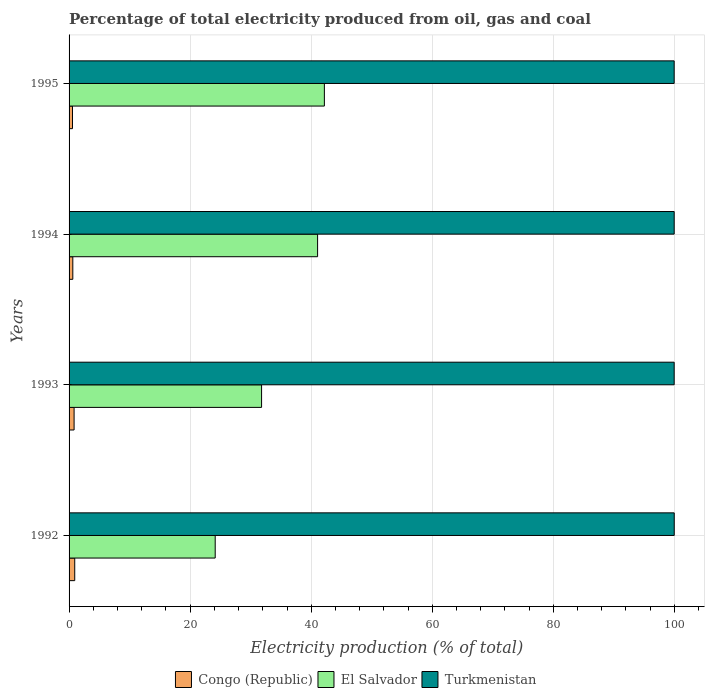How many groups of bars are there?
Provide a succinct answer. 4. Are the number of bars per tick equal to the number of legend labels?
Ensure brevity in your answer.  Yes. Are the number of bars on each tick of the Y-axis equal?
Your answer should be very brief. Yes. What is the electricity production in in Turkmenistan in 1995?
Your answer should be very brief. 99.96. Across all years, what is the maximum electricity production in in El Salvador?
Give a very brief answer. 42.18. Across all years, what is the minimum electricity production in in Turkmenistan?
Ensure brevity in your answer.  99.96. In which year was the electricity production in in Turkmenistan minimum?
Give a very brief answer. 1995. What is the total electricity production in in El Salvador in the graph?
Your answer should be compact. 139.17. What is the difference between the electricity production in in El Salvador in 1994 and that in 1995?
Offer a terse response. -1.12. What is the difference between the electricity production in in Turkmenistan in 1994 and the electricity production in in El Salvador in 1995?
Ensure brevity in your answer.  57.79. What is the average electricity production in in Turkmenistan per year?
Your response must be concise. 99.96. In the year 1994, what is the difference between the electricity production in in Congo (Republic) and electricity production in in El Salvador?
Make the answer very short. -40.44. What is the ratio of the electricity production in in Congo (Republic) in 1993 to that in 1994?
Ensure brevity in your answer.  1.34. Is the difference between the electricity production in in Congo (Republic) in 1993 and 1994 greater than the difference between the electricity production in in El Salvador in 1993 and 1994?
Offer a terse response. Yes. What is the difference between the highest and the second highest electricity production in in El Salvador?
Provide a succinct answer. 1.12. What is the difference between the highest and the lowest electricity production in in Turkmenistan?
Ensure brevity in your answer.  0.01. In how many years, is the electricity production in in Turkmenistan greater than the average electricity production in in Turkmenistan taken over all years?
Your response must be concise. 1. What does the 3rd bar from the top in 1994 represents?
Your answer should be compact. Congo (Republic). What does the 1st bar from the bottom in 1993 represents?
Your answer should be very brief. Congo (Republic). Is it the case that in every year, the sum of the electricity production in in El Salvador and electricity production in in Turkmenistan is greater than the electricity production in in Congo (Republic)?
Make the answer very short. Yes. How many bars are there?
Your response must be concise. 12. How many years are there in the graph?
Your answer should be compact. 4. Does the graph contain any zero values?
Your answer should be compact. No. Does the graph contain grids?
Offer a terse response. Yes. How are the legend labels stacked?
Your response must be concise. Horizontal. What is the title of the graph?
Your answer should be compact. Percentage of total electricity produced from oil, gas and coal. What is the label or title of the X-axis?
Ensure brevity in your answer.  Electricity production (% of total). What is the Electricity production (% of total) of Congo (Republic) in 1992?
Provide a short and direct response. 0.93. What is the Electricity production (% of total) in El Salvador in 1992?
Offer a very short reply. 24.14. What is the Electricity production (% of total) of Turkmenistan in 1992?
Your answer should be compact. 99.97. What is the Electricity production (% of total) of Congo (Republic) in 1993?
Your answer should be very brief. 0.83. What is the Electricity production (% of total) of El Salvador in 1993?
Provide a short and direct response. 31.8. What is the Electricity production (% of total) in Turkmenistan in 1993?
Make the answer very short. 99.96. What is the Electricity production (% of total) in Congo (Republic) in 1994?
Your answer should be very brief. 0.62. What is the Electricity production (% of total) in El Salvador in 1994?
Ensure brevity in your answer.  41.05. What is the Electricity production (% of total) of Turkmenistan in 1994?
Ensure brevity in your answer.  99.96. What is the Electricity production (% of total) of Congo (Republic) in 1995?
Your answer should be very brief. 0.56. What is the Electricity production (% of total) of El Salvador in 1995?
Your response must be concise. 42.18. What is the Electricity production (% of total) in Turkmenistan in 1995?
Your response must be concise. 99.96. Across all years, what is the maximum Electricity production (% of total) in Congo (Republic)?
Offer a very short reply. 0.93. Across all years, what is the maximum Electricity production (% of total) of El Salvador?
Your answer should be compact. 42.18. Across all years, what is the maximum Electricity production (% of total) in Turkmenistan?
Ensure brevity in your answer.  99.97. Across all years, what is the minimum Electricity production (% of total) in Congo (Republic)?
Keep it short and to the point. 0.56. Across all years, what is the minimum Electricity production (% of total) in El Salvador?
Keep it short and to the point. 24.14. Across all years, what is the minimum Electricity production (% of total) of Turkmenistan?
Offer a very short reply. 99.96. What is the total Electricity production (% of total) in Congo (Republic) in the graph?
Your response must be concise. 2.95. What is the total Electricity production (% of total) of El Salvador in the graph?
Give a very brief answer. 139.17. What is the total Electricity production (% of total) in Turkmenistan in the graph?
Provide a short and direct response. 399.85. What is the difference between the Electricity production (% of total) of Congo (Republic) in 1992 and that in 1993?
Your answer should be very brief. 0.11. What is the difference between the Electricity production (% of total) of El Salvador in 1992 and that in 1993?
Ensure brevity in your answer.  -7.66. What is the difference between the Electricity production (% of total) of Turkmenistan in 1992 and that in 1993?
Your answer should be compact. 0.01. What is the difference between the Electricity production (% of total) of Congo (Republic) in 1992 and that in 1994?
Give a very brief answer. 0.32. What is the difference between the Electricity production (% of total) of El Salvador in 1992 and that in 1994?
Your answer should be compact. -16.92. What is the difference between the Electricity production (% of total) of Turkmenistan in 1992 and that in 1994?
Your response must be concise. 0.01. What is the difference between the Electricity production (% of total) in Congo (Republic) in 1992 and that in 1995?
Your answer should be very brief. 0.37. What is the difference between the Electricity production (% of total) in El Salvador in 1992 and that in 1995?
Your answer should be very brief. -18.04. What is the difference between the Electricity production (% of total) of Turkmenistan in 1992 and that in 1995?
Offer a terse response. 0.01. What is the difference between the Electricity production (% of total) of Congo (Republic) in 1993 and that in 1994?
Offer a terse response. 0.21. What is the difference between the Electricity production (% of total) of El Salvador in 1993 and that in 1994?
Keep it short and to the point. -9.25. What is the difference between the Electricity production (% of total) of Turkmenistan in 1993 and that in 1994?
Keep it short and to the point. -0. What is the difference between the Electricity production (% of total) in Congo (Republic) in 1993 and that in 1995?
Provide a succinct answer. 0.26. What is the difference between the Electricity production (% of total) of El Salvador in 1993 and that in 1995?
Your answer should be compact. -10.38. What is the difference between the Electricity production (% of total) in Turkmenistan in 1993 and that in 1995?
Provide a short and direct response. 0. What is the difference between the Electricity production (% of total) in Congo (Republic) in 1994 and that in 1995?
Provide a succinct answer. 0.05. What is the difference between the Electricity production (% of total) of El Salvador in 1994 and that in 1995?
Offer a very short reply. -1.12. What is the difference between the Electricity production (% of total) in Turkmenistan in 1994 and that in 1995?
Offer a terse response. 0. What is the difference between the Electricity production (% of total) of Congo (Republic) in 1992 and the Electricity production (% of total) of El Salvador in 1993?
Your answer should be compact. -30.87. What is the difference between the Electricity production (% of total) in Congo (Republic) in 1992 and the Electricity production (% of total) in Turkmenistan in 1993?
Your answer should be very brief. -99.03. What is the difference between the Electricity production (% of total) of El Salvador in 1992 and the Electricity production (% of total) of Turkmenistan in 1993?
Give a very brief answer. -75.82. What is the difference between the Electricity production (% of total) of Congo (Republic) in 1992 and the Electricity production (% of total) of El Salvador in 1994?
Offer a terse response. -40.12. What is the difference between the Electricity production (% of total) of Congo (Republic) in 1992 and the Electricity production (% of total) of Turkmenistan in 1994?
Offer a very short reply. -99.03. What is the difference between the Electricity production (% of total) in El Salvador in 1992 and the Electricity production (% of total) in Turkmenistan in 1994?
Give a very brief answer. -75.82. What is the difference between the Electricity production (% of total) in Congo (Republic) in 1992 and the Electricity production (% of total) in El Salvador in 1995?
Make the answer very short. -41.24. What is the difference between the Electricity production (% of total) in Congo (Republic) in 1992 and the Electricity production (% of total) in Turkmenistan in 1995?
Provide a succinct answer. -99.02. What is the difference between the Electricity production (% of total) in El Salvador in 1992 and the Electricity production (% of total) in Turkmenistan in 1995?
Your answer should be compact. -75.82. What is the difference between the Electricity production (% of total) of Congo (Republic) in 1993 and the Electricity production (% of total) of El Salvador in 1994?
Make the answer very short. -40.23. What is the difference between the Electricity production (% of total) in Congo (Republic) in 1993 and the Electricity production (% of total) in Turkmenistan in 1994?
Your answer should be very brief. -99.13. What is the difference between the Electricity production (% of total) in El Salvador in 1993 and the Electricity production (% of total) in Turkmenistan in 1994?
Ensure brevity in your answer.  -68.16. What is the difference between the Electricity production (% of total) of Congo (Republic) in 1993 and the Electricity production (% of total) of El Salvador in 1995?
Give a very brief answer. -41.35. What is the difference between the Electricity production (% of total) in Congo (Republic) in 1993 and the Electricity production (% of total) in Turkmenistan in 1995?
Provide a short and direct response. -99.13. What is the difference between the Electricity production (% of total) in El Salvador in 1993 and the Electricity production (% of total) in Turkmenistan in 1995?
Offer a terse response. -68.16. What is the difference between the Electricity production (% of total) of Congo (Republic) in 1994 and the Electricity production (% of total) of El Salvador in 1995?
Provide a succinct answer. -41.56. What is the difference between the Electricity production (% of total) in Congo (Republic) in 1994 and the Electricity production (% of total) in Turkmenistan in 1995?
Offer a very short reply. -99.34. What is the difference between the Electricity production (% of total) in El Salvador in 1994 and the Electricity production (% of total) in Turkmenistan in 1995?
Keep it short and to the point. -58.9. What is the average Electricity production (% of total) in Congo (Republic) per year?
Make the answer very short. 0.74. What is the average Electricity production (% of total) of El Salvador per year?
Offer a terse response. 34.79. What is the average Electricity production (% of total) of Turkmenistan per year?
Offer a terse response. 99.96. In the year 1992, what is the difference between the Electricity production (% of total) of Congo (Republic) and Electricity production (% of total) of El Salvador?
Keep it short and to the point. -23.2. In the year 1992, what is the difference between the Electricity production (% of total) in Congo (Republic) and Electricity production (% of total) in Turkmenistan?
Offer a very short reply. -99.04. In the year 1992, what is the difference between the Electricity production (% of total) of El Salvador and Electricity production (% of total) of Turkmenistan?
Give a very brief answer. -75.83. In the year 1993, what is the difference between the Electricity production (% of total) in Congo (Republic) and Electricity production (% of total) in El Salvador?
Make the answer very short. -30.97. In the year 1993, what is the difference between the Electricity production (% of total) in Congo (Republic) and Electricity production (% of total) in Turkmenistan?
Keep it short and to the point. -99.13. In the year 1993, what is the difference between the Electricity production (% of total) in El Salvador and Electricity production (% of total) in Turkmenistan?
Ensure brevity in your answer.  -68.16. In the year 1994, what is the difference between the Electricity production (% of total) of Congo (Republic) and Electricity production (% of total) of El Salvador?
Ensure brevity in your answer.  -40.44. In the year 1994, what is the difference between the Electricity production (% of total) of Congo (Republic) and Electricity production (% of total) of Turkmenistan?
Ensure brevity in your answer.  -99.34. In the year 1994, what is the difference between the Electricity production (% of total) in El Salvador and Electricity production (% of total) in Turkmenistan?
Your response must be concise. -58.91. In the year 1995, what is the difference between the Electricity production (% of total) in Congo (Republic) and Electricity production (% of total) in El Salvador?
Make the answer very short. -41.61. In the year 1995, what is the difference between the Electricity production (% of total) of Congo (Republic) and Electricity production (% of total) of Turkmenistan?
Make the answer very short. -99.39. In the year 1995, what is the difference between the Electricity production (% of total) in El Salvador and Electricity production (% of total) in Turkmenistan?
Make the answer very short. -57.78. What is the ratio of the Electricity production (% of total) of Congo (Republic) in 1992 to that in 1993?
Ensure brevity in your answer.  1.13. What is the ratio of the Electricity production (% of total) of El Salvador in 1992 to that in 1993?
Give a very brief answer. 0.76. What is the ratio of the Electricity production (% of total) in Turkmenistan in 1992 to that in 1993?
Provide a short and direct response. 1. What is the ratio of the Electricity production (% of total) of Congo (Republic) in 1992 to that in 1994?
Offer a terse response. 1.51. What is the ratio of the Electricity production (% of total) in El Salvador in 1992 to that in 1994?
Your answer should be very brief. 0.59. What is the ratio of the Electricity production (% of total) in Turkmenistan in 1992 to that in 1994?
Ensure brevity in your answer.  1. What is the ratio of the Electricity production (% of total) in Congo (Republic) in 1992 to that in 1995?
Ensure brevity in your answer.  1.65. What is the ratio of the Electricity production (% of total) in El Salvador in 1992 to that in 1995?
Your answer should be compact. 0.57. What is the ratio of the Electricity production (% of total) of Congo (Republic) in 1993 to that in 1994?
Your answer should be compact. 1.34. What is the ratio of the Electricity production (% of total) in El Salvador in 1993 to that in 1994?
Give a very brief answer. 0.77. What is the ratio of the Electricity production (% of total) of Congo (Republic) in 1993 to that in 1995?
Give a very brief answer. 1.47. What is the ratio of the Electricity production (% of total) of El Salvador in 1993 to that in 1995?
Give a very brief answer. 0.75. What is the ratio of the Electricity production (% of total) of Turkmenistan in 1993 to that in 1995?
Provide a short and direct response. 1. What is the ratio of the Electricity production (% of total) of Congo (Republic) in 1994 to that in 1995?
Provide a short and direct response. 1.09. What is the ratio of the Electricity production (% of total) of El Salvador in 1994 to that in 1995?
Keep it short and to the point. 0.97. What is the difference between the highest and the second highest Electricity production (% of total) in Congo (Republic)?
Make the answer very short. 0.11. What is the difference between the highest and the second highest Electricity production (% of total) in El Salvador?
Provide a succinct answer. 1.12. What is the difference between the highest and the second highest Electricity production (% of total) of Turkmenistan?
Provide a succinct answer. 0.01. What is the difference between the highest and the lowest Electricity production (% of total) of Congo (Republic)?
Provide a short and direct response. 0.37. What is the difference between the highest and the lowest Electricity production (% of total) in El Salvador?
Your response must be concise. 18.04. What is the difference between the highest and the lowest Electricity production (% of total) of Turkmenistan?
Your response must be concise. 0.01. 